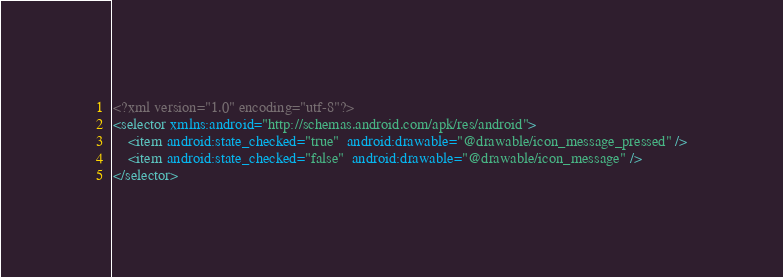Convert code to text. <code><loc_0><loc_0><loc_500><loc_500><_XML_><?xml version="1.0" encoding="utf-8"?>
<selector xmlns:android="http://schemas.android.com/apk/res/android">
    <item android:state_checked="true"  android:drawable="@drawable/icon_message_pressed" />
    <item android:state_checked="false"  android:drawable="@drawable/icon_message" />
</selector></code> 